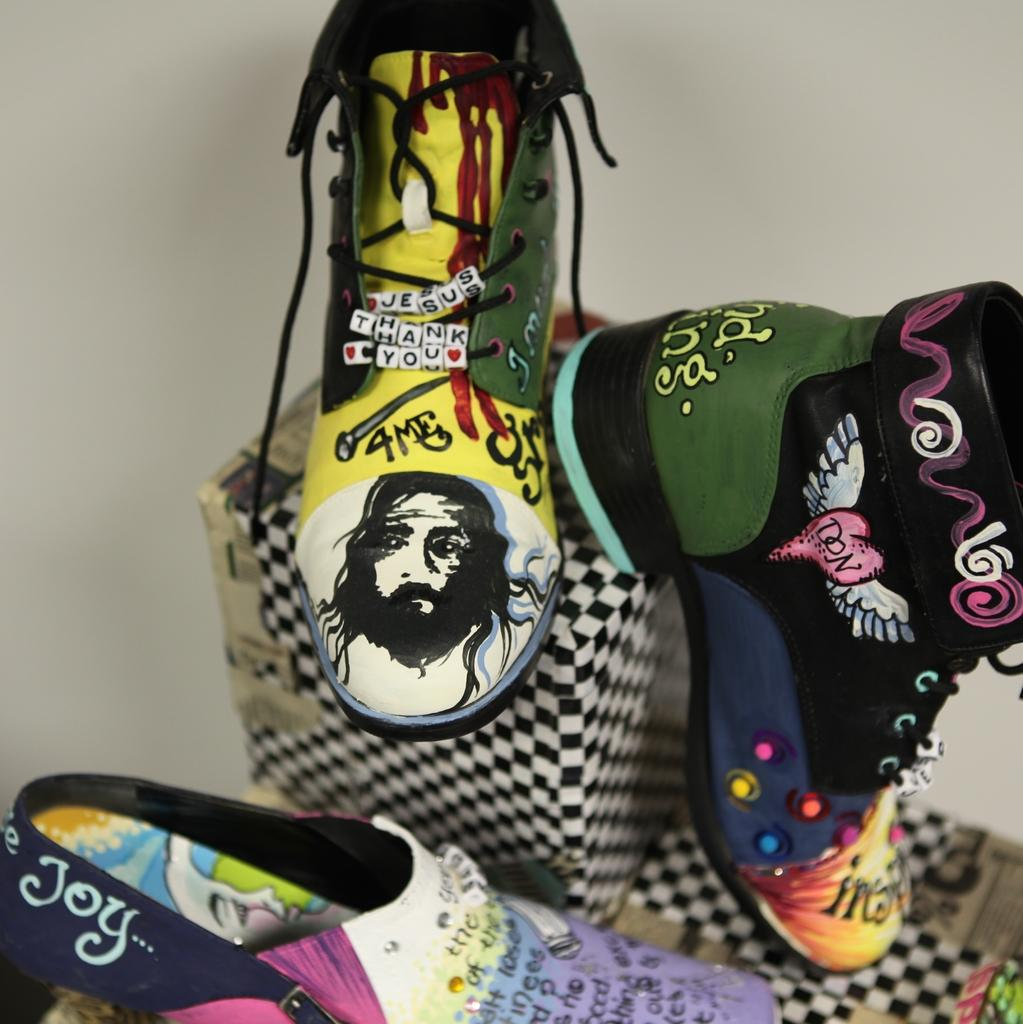What types of items are in the image? There are different types of shoes in the image. How are the shoes arranged or displayed? The shoes are kept on cotton boxers. What can be seen in the background of the image? There is a wall in the image. What type of glove is being used in the battle depicted in the image? There is no glove or battle present in the image; it features different types of shoes on cotton boxers with a wall in the background. 